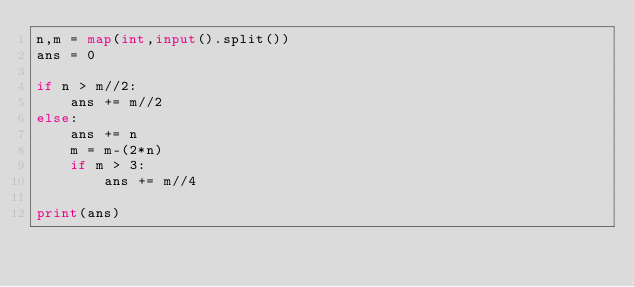<code> <loc_0><loc_0><loc_500><loc_500><_Python_>n,m = map(int,input().split())
ans = 0

if n > m//2:
    ans += m//2
else:
    ans += n
    m = m-(2*n)
    if m > 3:
        ans += m//4

print(ans)</code> 